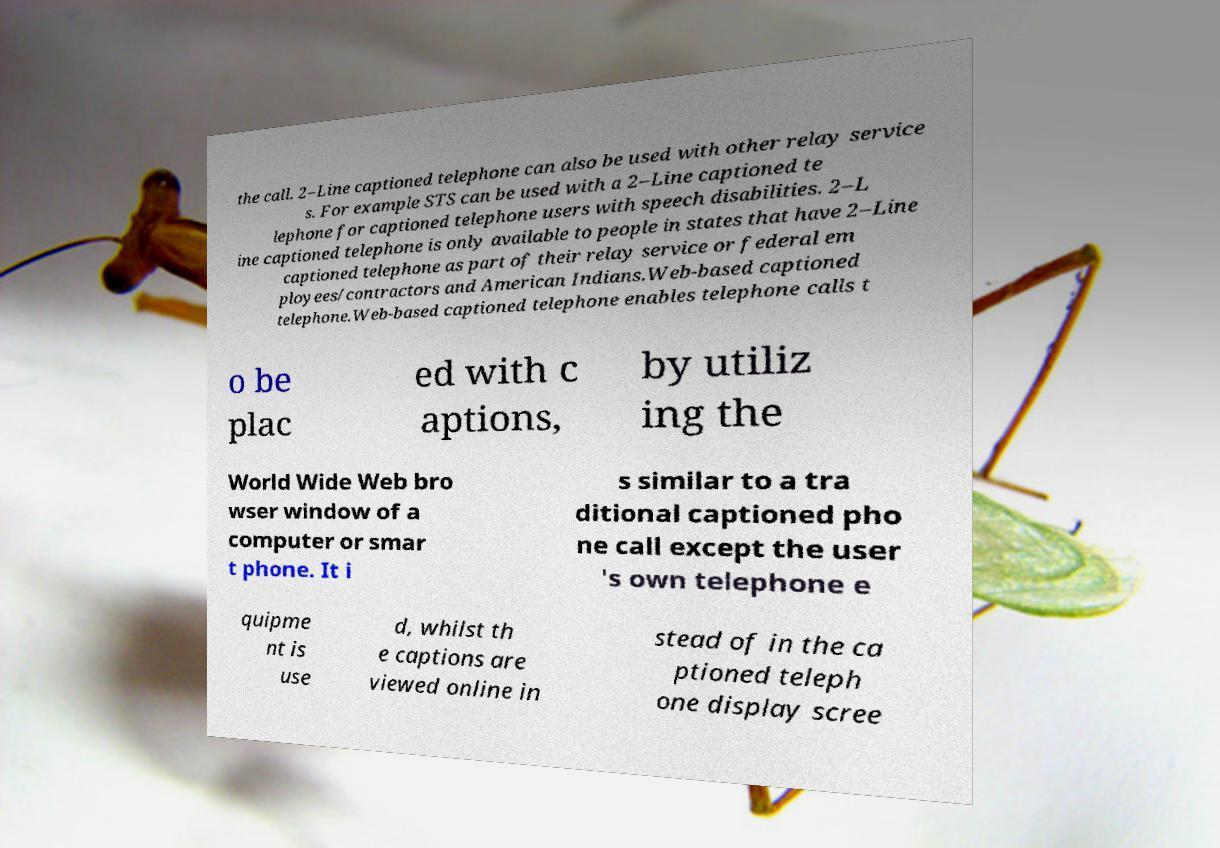Could you extract and type out the text from this image? the call. 2–Line captioned telephone can also be used with other relay service s. For example STS can be used with a 2–Line captioned te lephone for captioned telephone users with speech disabilities. 2–L ine captioned telephone is only available to people in states that have 2–Line captioned telephone as part of their relay service or federal em ployees/contractors and American Indians.Web-based captioned telephone.Web-based captioned telephone enables telephone calls t o be plac ed with c aptions, by utiliz ing the World Wide Web bro wser window of a computer or smar t phone. It i s similar to a tra ditional captioned pho ne call except the user 's own telephone e quipme nt is use d, whilst th e captions are viewed online in stead of in the ca ptioned teleph one display scree 